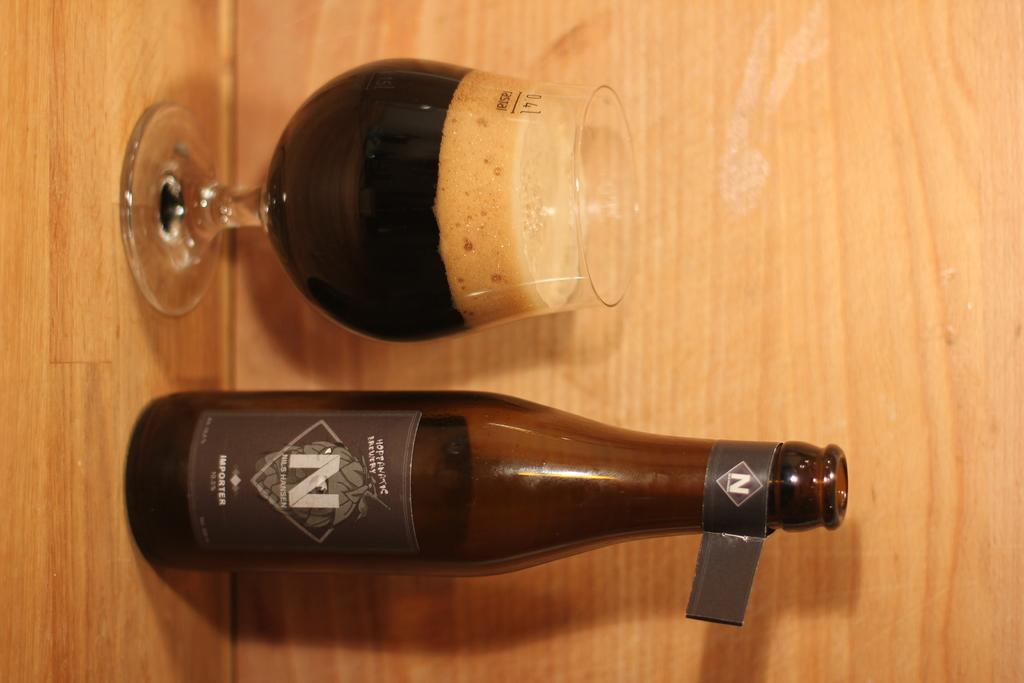<image>
Render a clear and concise summary of the photo. A bottle has a large N on the label and a glass next to it. 